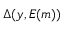Convert formula to latex. <formula><loc_0><loc_0><loc_500><loc_500>\Delta ( y , E ( m ) )</formula> 